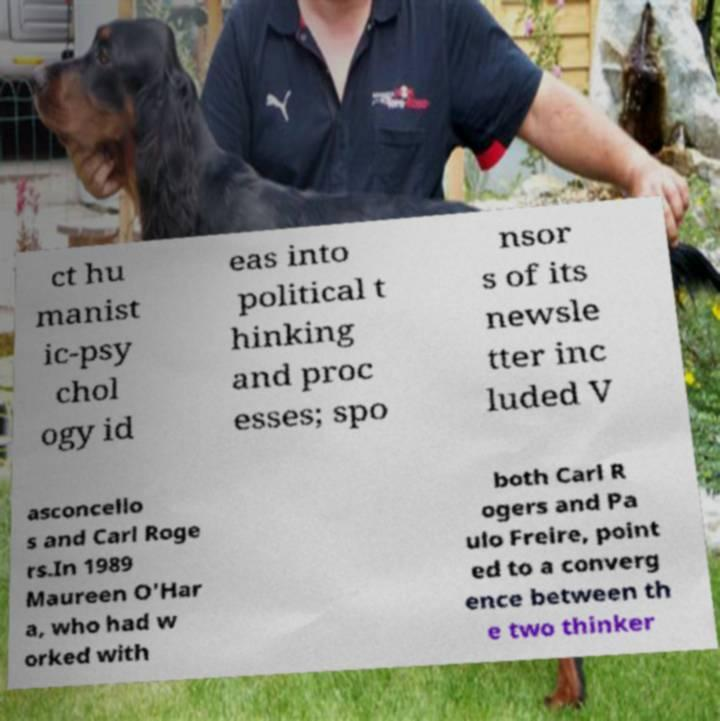Can you accurately transcribe the text from the provided image for me? ct hu manist ic-psy chol ogy id eas into political t hinking and proc esses; spo nsor s of its newsle tter inc luded V asconcello s and Carl Roge rs.In 1989 Maureen O'Har a, who had w orked with both Carl R ogers and Pa ulo Freire, point ed to a converg ence between th e two thinker 